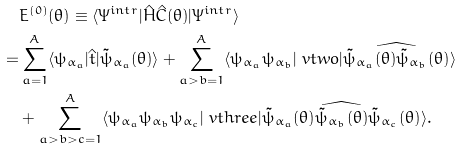<formula> <loc_0><loc_0><loc_500><loc_500>& E ^ { ( 0 ) } ( \theta ) \equiv \langle \Psi ^ { i n t r } | \hat { H } \hat { C } ( \theta ) | \Psi ^ { i n t r } \rangle \\ = & \sum _ { a = 1 } ^ { A } \langle \psi _ { \alpha _ { a } } | \hat { t } | \tilde { \psi } _ { \alpha _ { a } } ( \theta ) \rangle + \sum _ { a > b = 1 } ^ { A } \langle \psi _ { \alpha _ { a } } \psi _ { \alpha _ { b } } | \ v t w o | \widehat { \tilde { \psi } _ { \alpha _ { a } } ( \theta ) \tilde { \psi } _ { \alpha _ { b } } ( \theta ) } \rangle \\ & + \sum _ { a > b > c = 1 } ^ { A } \langle \psi _ { \alpha _ { a } } \psi _ { \alpha _ { b } } \psi _ { \alpha _ { c } } | \ v t h r e e | \widehat { \tilde { \psi } _ { \alpha _ { a } } ( \theta ) \tilde { \psi } _ { \alpha _ { b } } ( \theta ) \tilde { \psi } _ { \alpha _ { c } } ( \theta ) } \rangle .</formula> 